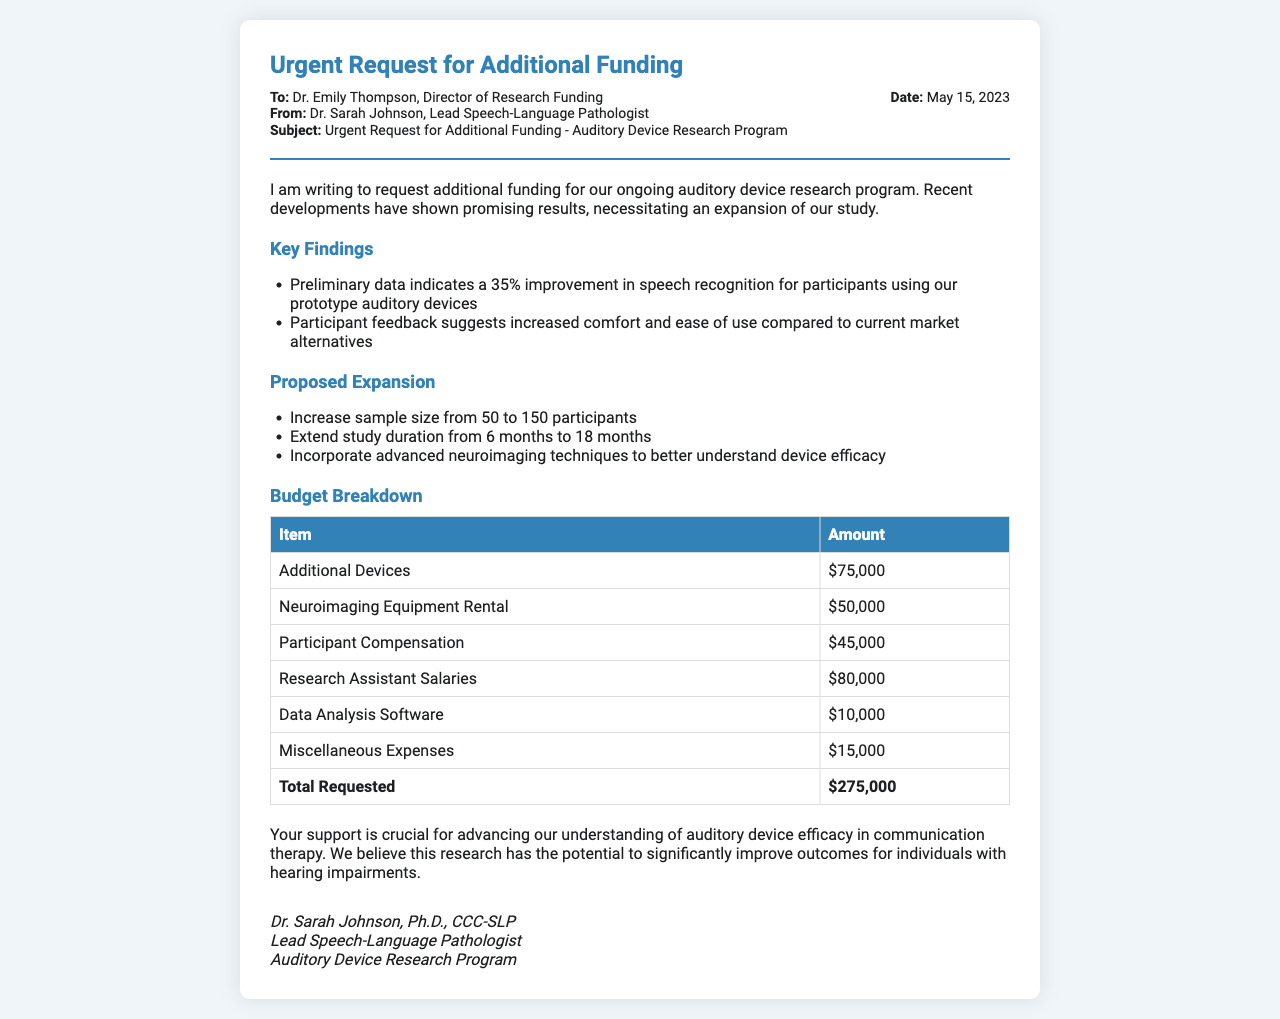what is the total requested funding? The total requested funding is clearly stated in the budget section of the document as $275,000.
Answer: $275,000 who is the director of research funding? The document specifies that Dr. Emily Thompson is the Director of Research Funding.
Answer: Dr. Emily Thompson how many participants are proposed for the study expansion? The proposed sample size for the study expansion is from 50 to 150 participants, indicating an increase of 100 participants.
Answer: 150 participants what is the date of the funding request? The date mentioned in the header of the document for the funding request is May 15, 2023.
Answer: May 15, 2023 what is one of the key findings related to speech recognition? One of the key findings noted in the document is a 35% improvement in speech recognition for participants using the prototype auditory devices.
Answer: 35% improvement how long is the study duration to be extended? The document states that the study duration is proposed to be extended from 6 months to 18 months.
Answer: 18 months which item has the highest cost in the budget breakdown? The highest cost in the budget breakdown is for Research Assistant Salaries, which is $80,000.
Answer: Research Assistant Salaries what are the miscellaneous expenses estimated at? The document lists the miscellaneous expenses as being estimated at $15,000.
Answer: $15,000 who is the lead speech-language pathologist? The lead speech-language pathologist mentioned at the end of the document is Dr. Sarah Johnson.
Answer: Dr. Sarah Johnson 